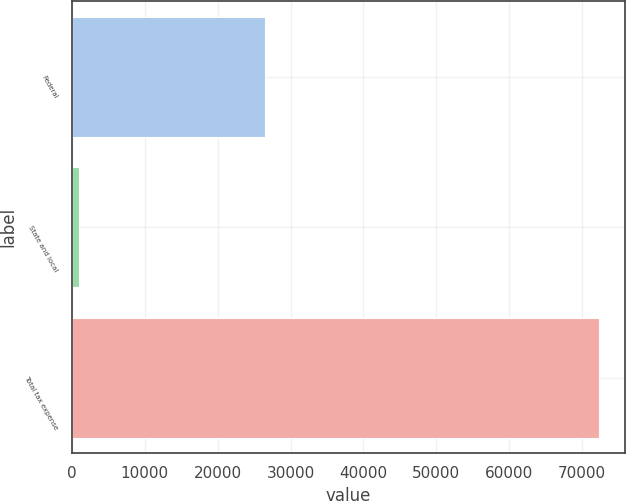Convert chart to OTSL. <chart><loc_0><loc_0><loc_500><loc_500><bar_chart><fcel>Federal<fcel>State and local<fcel>Total tax expense<nl><fcel>26439<fcel>1028<fcel>72270<nl></chart> 